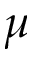<formula> <loc_0><loc_0><loc_500><loc_500>\mu</formula> 